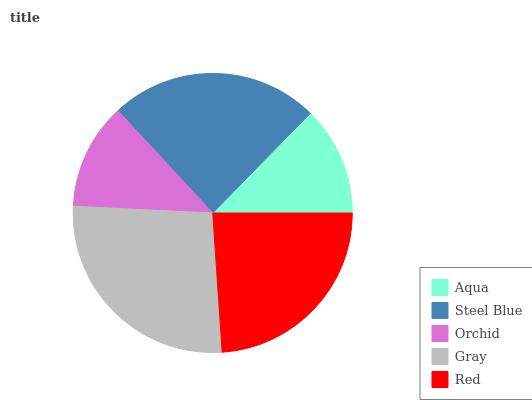Is Orchid the minimum?
Answer yes or no. Yes. Is Gray the maximum?
Answer yes or no. Yes. Is Steel Blue the minimum?
Answer yes or no. No. Is Steel Blue the maximum?
Answer yes or no. No. Is Steel Blue greater than Aqua?
Answer yes or no. Yes. Is Aqua less than Steel Blue?
Answer yes or no. Yes. Is Aqua greater than Steel Blue?
Answer yes or no. No. Is Steel Blue less than Aqua?
Answer yes or no. No. Is Red the high median?
Answer yes or no. Yes. Is Red the low median?
Answer yes or no. Yes. Is Aqua the high median?
Answer yes or no. No. Is Aqua the low median?
Answer yes or no. No. 